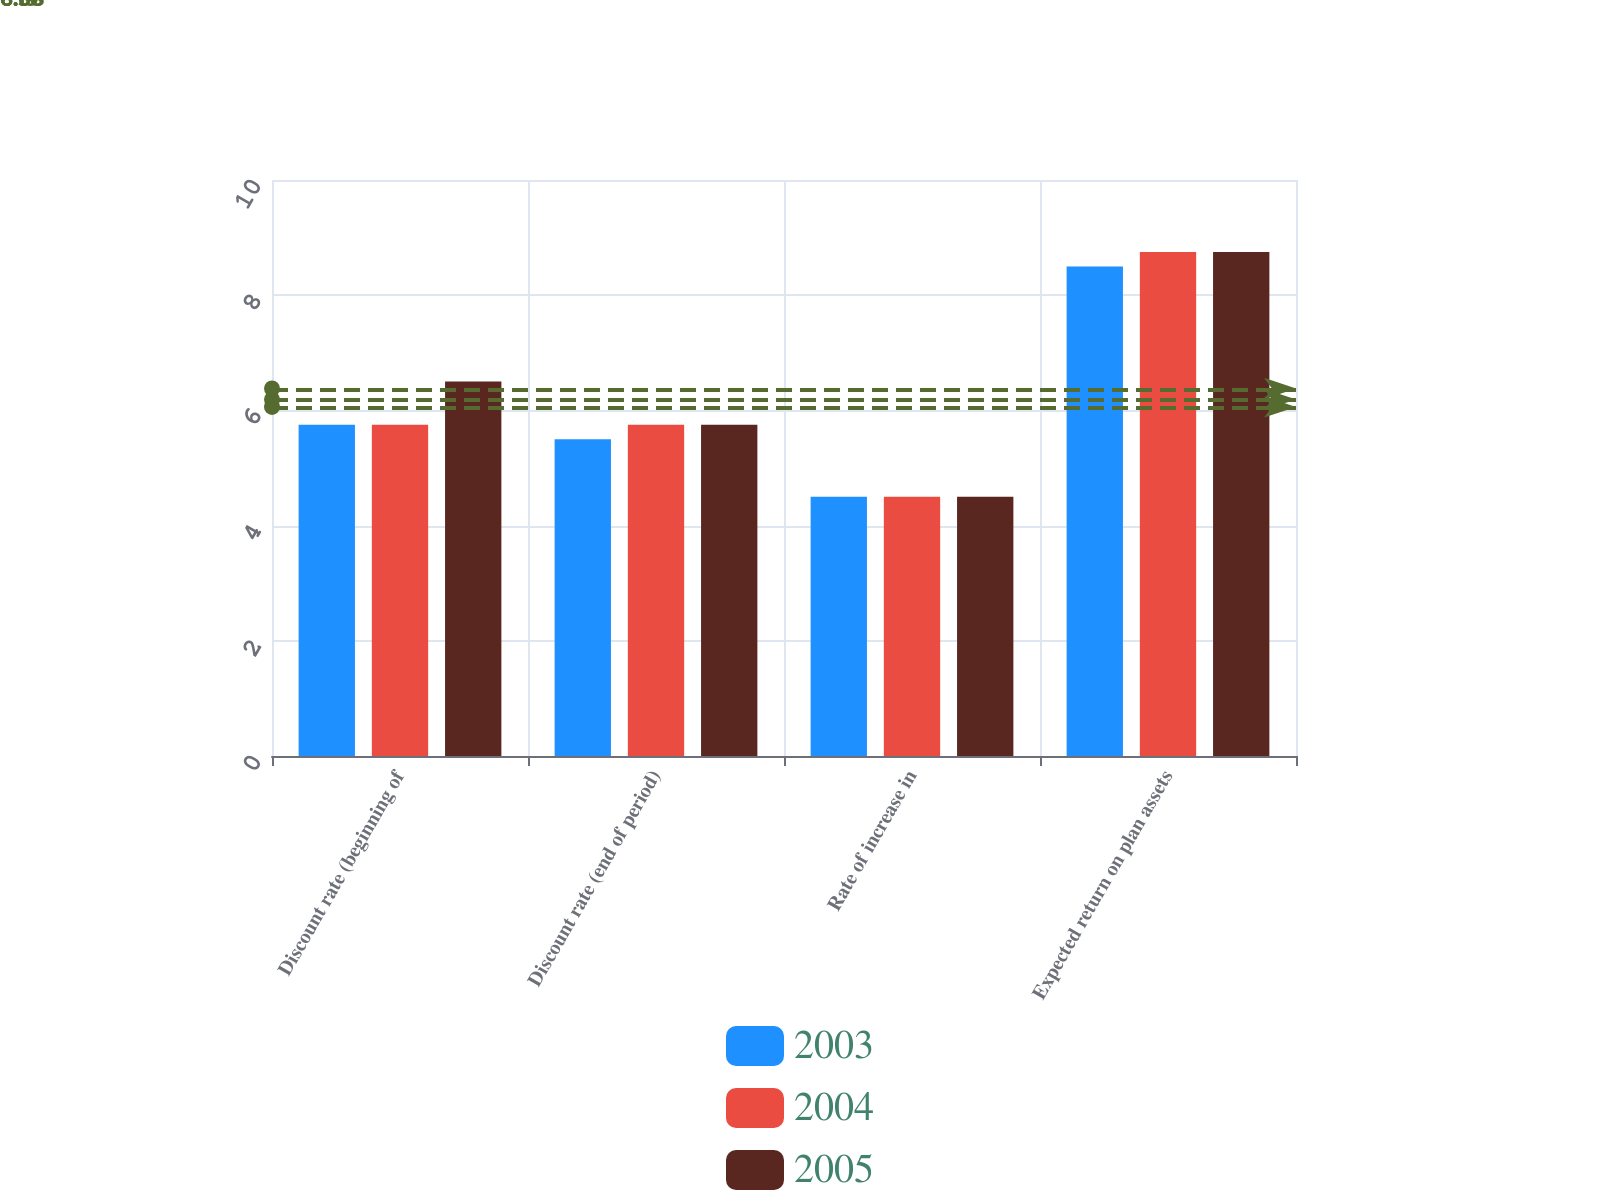Convert chart. <chart><loc_0><loc_0><loc_500><loc_500><stacked_bar_chart><ecel><fcel>Discount rate (beginning of<fcel>Discount rate (end of period)<fcel>Rate of increase in<fcel>Expected return on plan assets<nl><fcel>2003<fcel>5.75<fcel>5.5<fcel>4.5<fcel>8.5<nl><fcel>2004<fcel>5.75<fcel>5.75<fcel>4.5<fcel>8.75<nl><fcel>2005<fcel>6.5<fcel>5.75<fcel>4.5<fcel>8.75<nl></chart> 